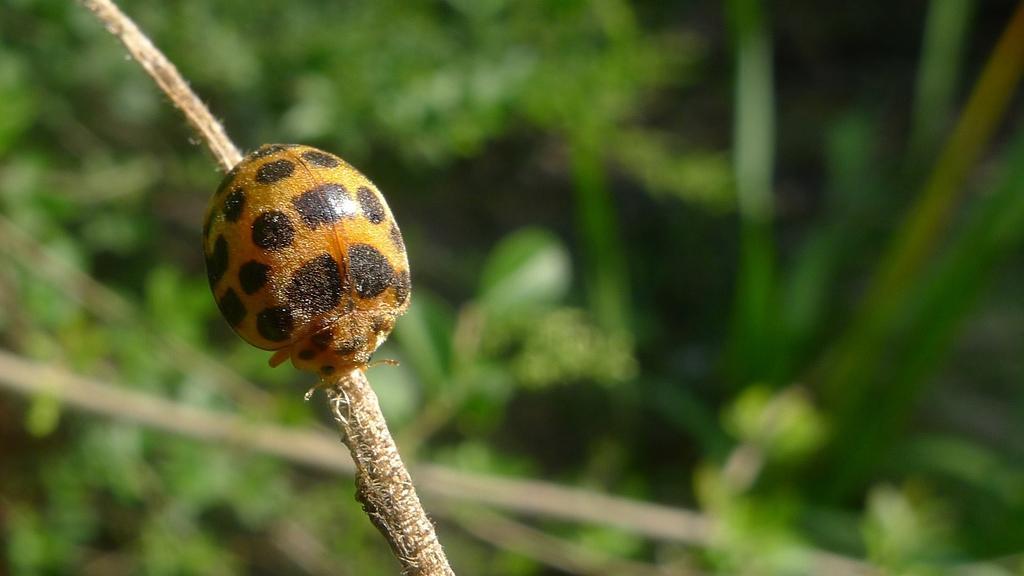Describe this image in one or two sentences. In this image there is an insect on the stem. Behind there are few plants having leaves. 